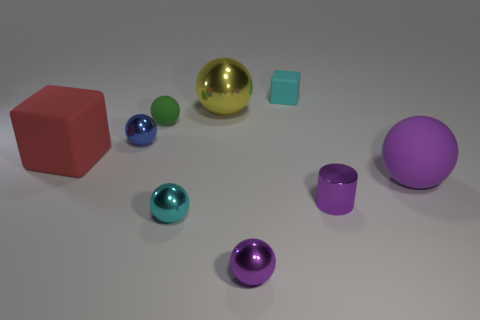The object that is the same color as the tiny rubber cube is what shape?
Give a very brief answer. Sphere. What is the large purple sphere made of?
Offer a very short reply. Rubber. Is the large purple object made of the same material as the small purple cylinder?
Provide a short and direct response. No. How many metal objects are either large purple cylinders or tiny purple cylinders?
Give a very brief answer. 1. There is a tiny cyan object that is behind the large red matte cube; what shape is it?
Provide a short and direct response. Cube. What is the size of the cyan object that is the same material as the big block?
Provide a succinct answer. Small. There is a small shiny thing that is left of the large yellow sphere and in front of the purple matte sphere; what is its shape?
Provide a succinct answer. Sphere. There is a large matte thing that is on the right side of the shiny cylinder; is its color the same as the tiny metallic cylinder?
Give a very brief answer. Yes. Do the tiny cyan object behind the red cube and the big matte object that is to the left of the large rubber sphere have the same shape?
Your response must be concise. Yes. How big is the green thing to the right of the red matte block?
Offer a terse response. Small. 